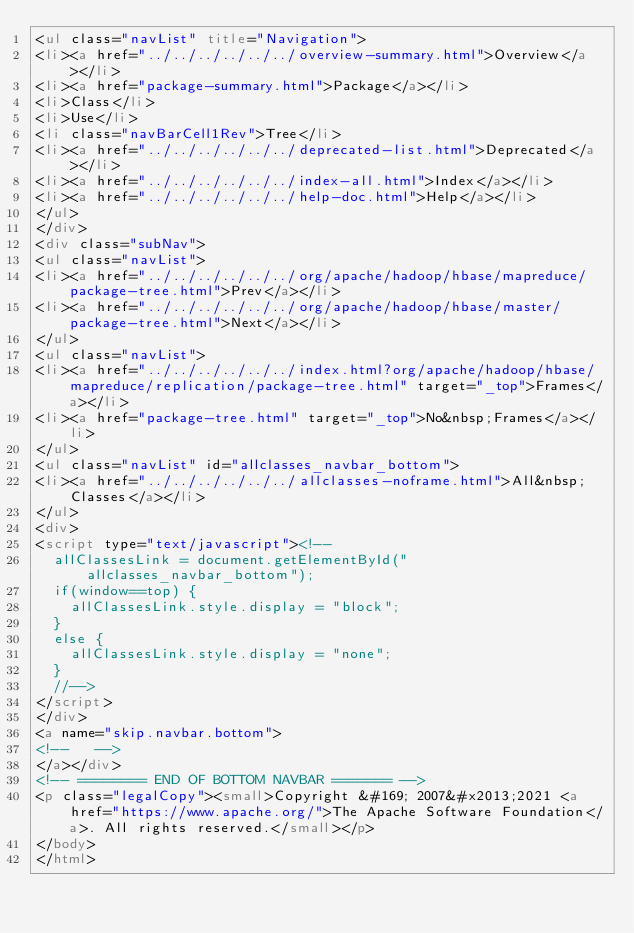<code> <loc_0><loc_0><loc_500><loc_500><_HTML_><ul class="navList" title="Navigation">
<li><a href="../../../../../../overview-summary.html">Overview</a></li>
<li><a href="package-summary.html">Package</a></li>
<li>Class</li>
<li>Use</li>
<li class="navBarCell1Rev">Tree</li>
<li><a href="../../../../../../deprecated-list.html">Deprecated</a></li>
<li><a href="../../../../../../index-all.html">Index</a></li>
<li><a href="../../../../../../help-doc.html">Help</a></li>
</ul>
</div>
<div class="subNav">
<ul class="navList">
<li><a href="../../../../../../org/apache/hadoop/hbase/mapreduce/package-tree.html">Prev</a></li>
<li><a href="../../../../../../org/apache/hadoop/hbase/master/package-tree.html">Next</a></li>
</ul>
<ul class="navList">
<li><a href="../../../../../../index.html?org/apache/hadoop/hbase/mapreduce/replication/package-tree.html" target="_top">Frames</a></li>
<li><a href="package-tree.html" target="_top">No&nbsp;Frames</a></li>
</ul>
<ul class="navList" id="allclasses_navbar_bottom">
<li><a href="../../../../../../allclasses-noframe.html">All&nbsp;Classes</a></li>
</ul>
<div>
<script type="text/javascript"><!--
  allClassesLink = document.getElementById("allclasses_navbar_bottom");
  if(window==top) {
    allClassesLink.style.display = "block";
  }
  else {
    allClassesLink.style.display = "none";
  }
  //-->
</script>
</div>
<a name="skip.navbar.bottom">
<!--   -->
</a></div>
<!-- ======== END OF BOTTOM NAVBAR ======= -->
<p class="legalCopy"><small>Copyright &#169; 2007&#x2013;2021 <a href="https://www.apache.org/">The Apache Software Foundation</a>. All rights reserved.</small></p>
</body>
</html>
</code> 